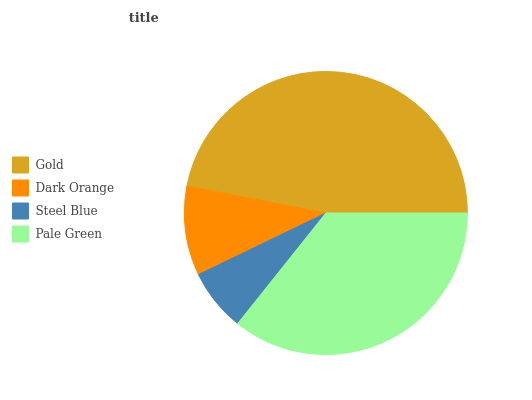Is Steel Blue the minimum?
Answer yes or no. Yes. Is Gold the maximum?
Answer yes or no. Yes. Is Dark Orange the minimum?
Answer yes or no. No. Is Dark Orange the maximum?
Answer yes or no. No. Is Gold greater than Dark Orange?
Answer yes or no. Yes. Is Dark Orange less than Gold?
Answer yes or no. Yes. Is Dark Orange greater than Gold?
Answer yes or no. No. Is Gold less than Dark Orange?
Answer yes or no. No. Is Pale Green the high median?
Answer yes or no. Yes. Is Dark Orange the low median?
Answer yes or no. Yes. Is Dark Orange the high median?
Answer yes or no. No. Is Gold the low median?
Answer yes or no. No. 